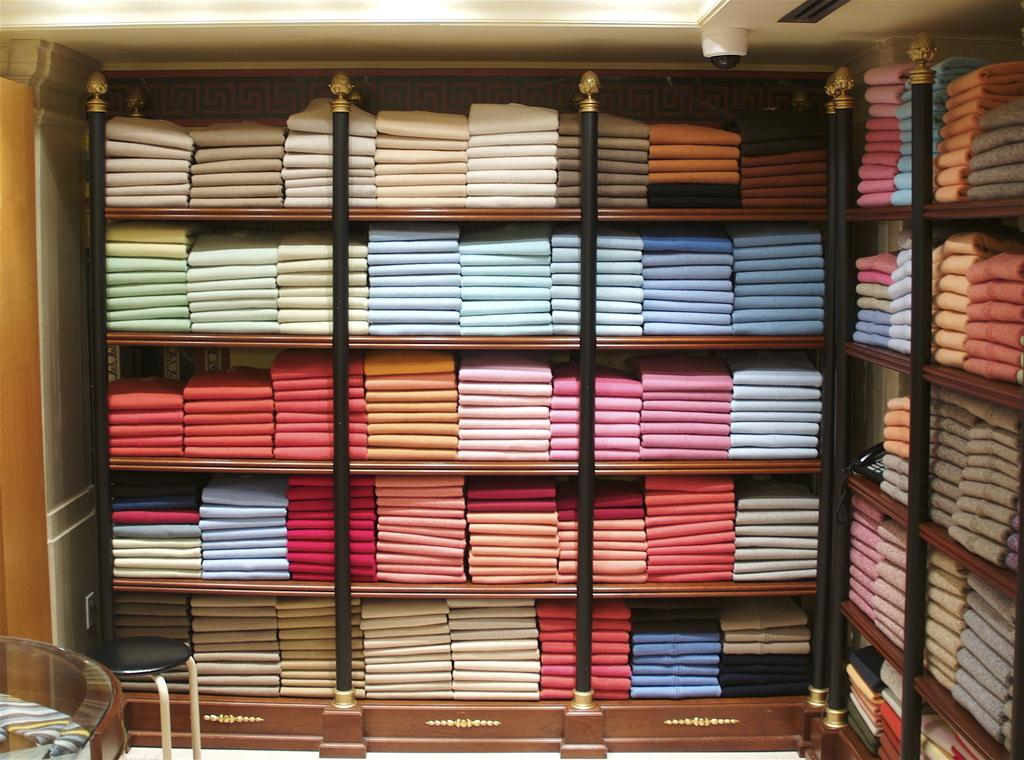What type of items can be seen in the shelves in the image? There are clothes in the shelves in the image. What piece of furniture is present in the image that can be used for sitting? There is a stool in the image. What type of table is visible in the image? There is a glass table in the image. What type of lighting is present in the image? There are lights on the ceiling in the image. Can you see any cables on the table in the image? There are no cables visible on the table in the image. 